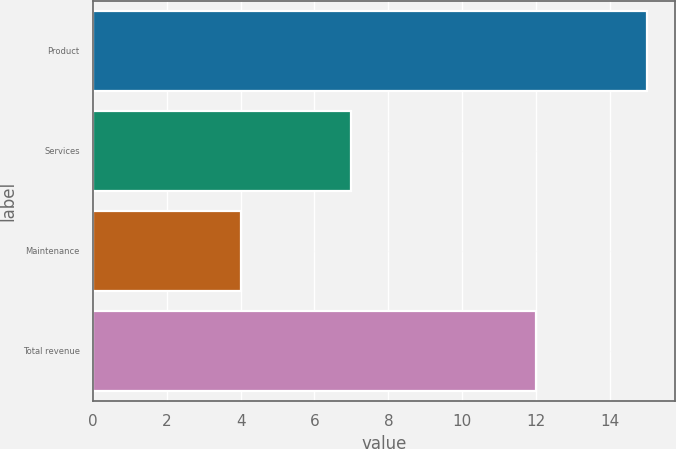Convert chart. <chart><loc_0><loc_0><loc_500><loc_500><bar_chart><fcel>Product<fcel>Services<fcel>Maintenance<fcel>Total revenue<nl><fcel>15<fcel>7<fcel>4<fcel>12<nl></chart> 